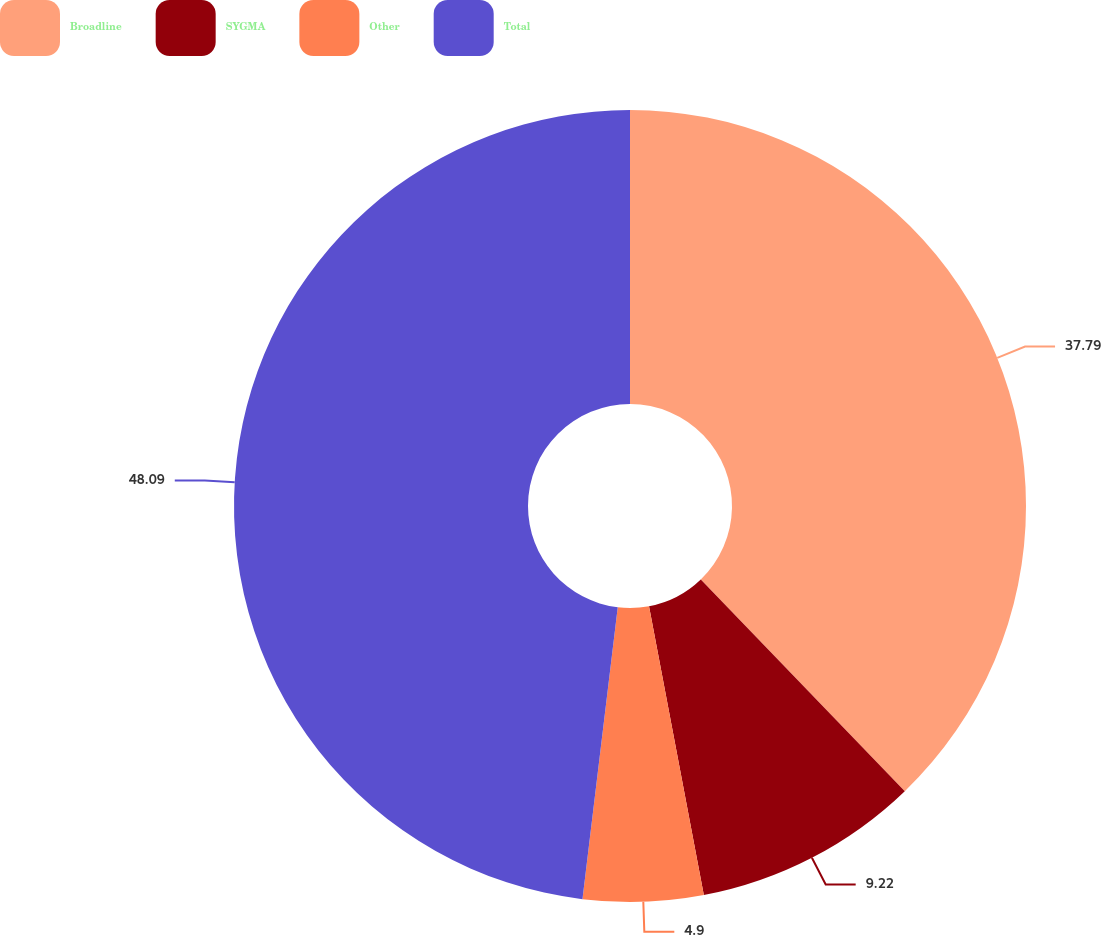<chart> <loc_0><loc_0><loc_500><loc_500><pie_chart><fcel>Broadline<fcel>SYGMA<fcel>Other<fcel>Total<nl><fcel>37.79%<fcel>9.22%<fcel>4.9%<fcel>48.08%<nl></chart> 